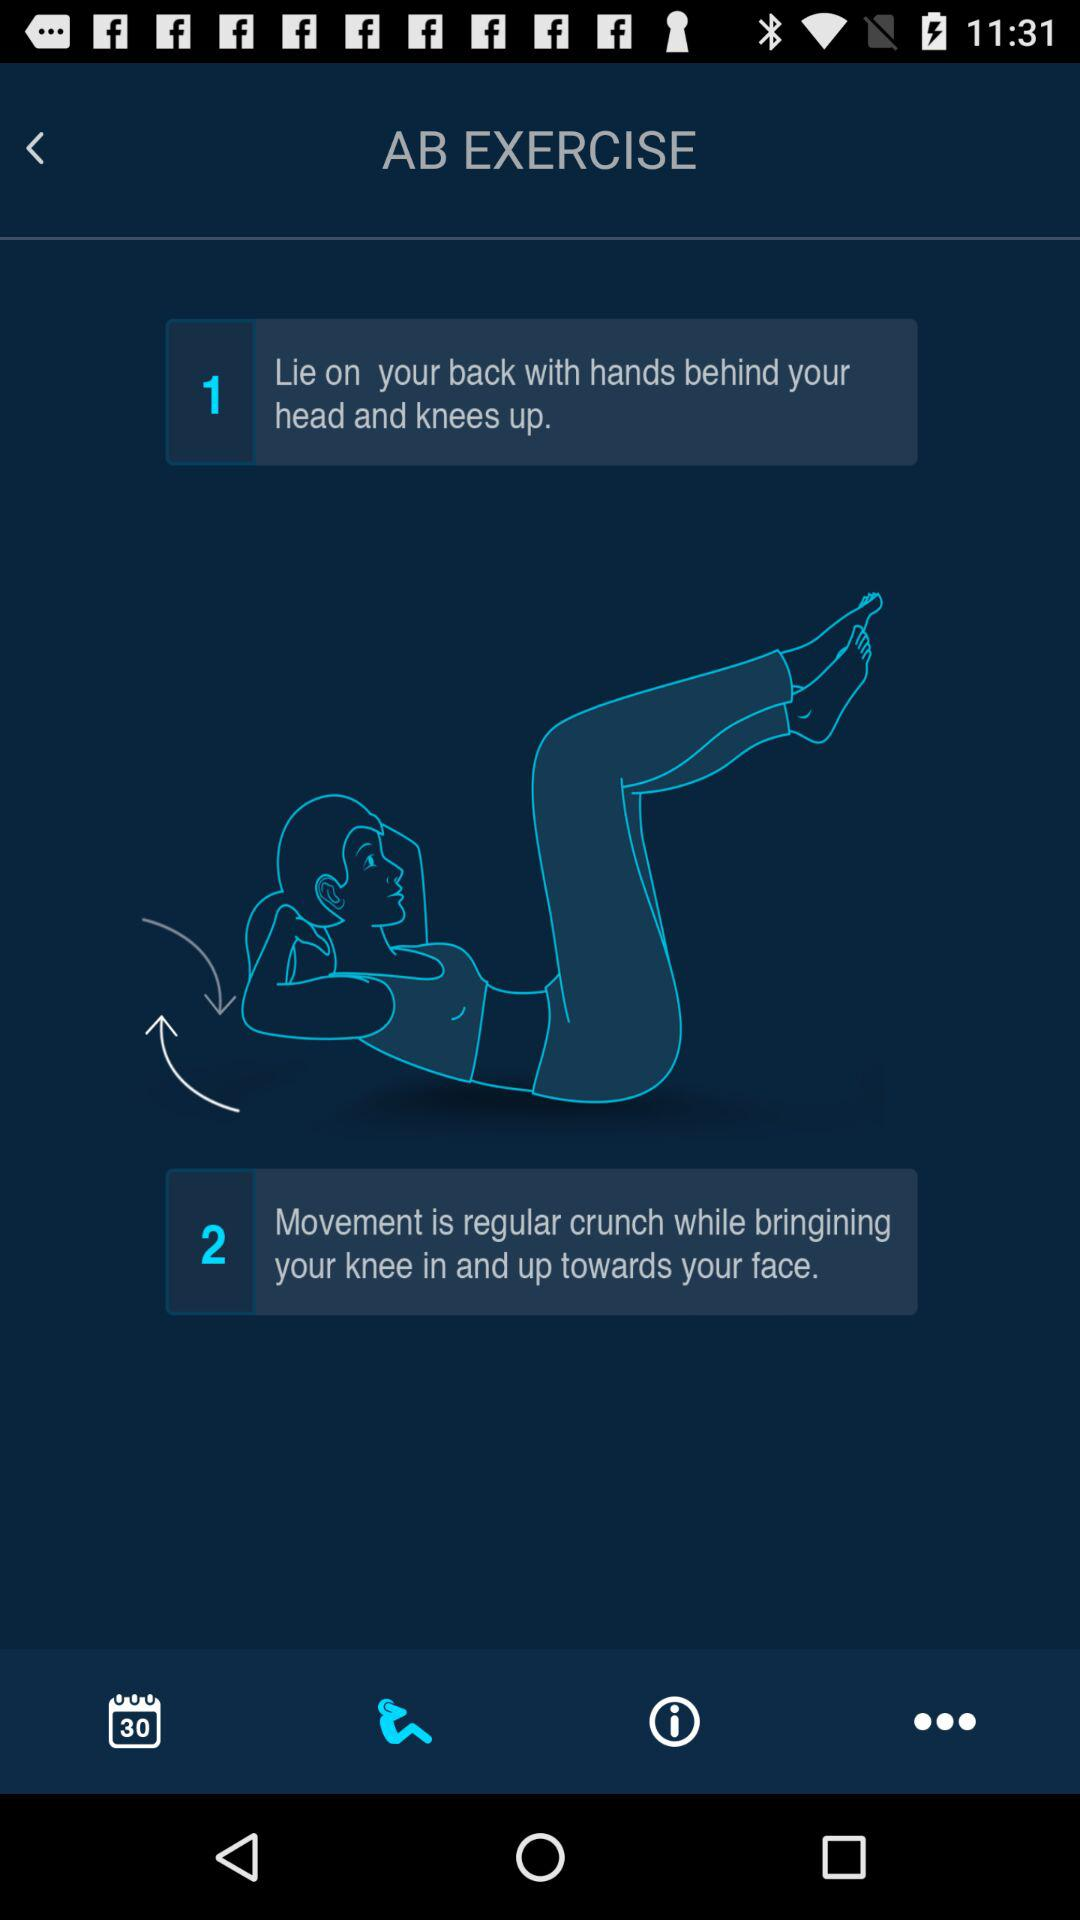How many instructions are there for this exercise?
Answer the question using a single word or phrase. 2 